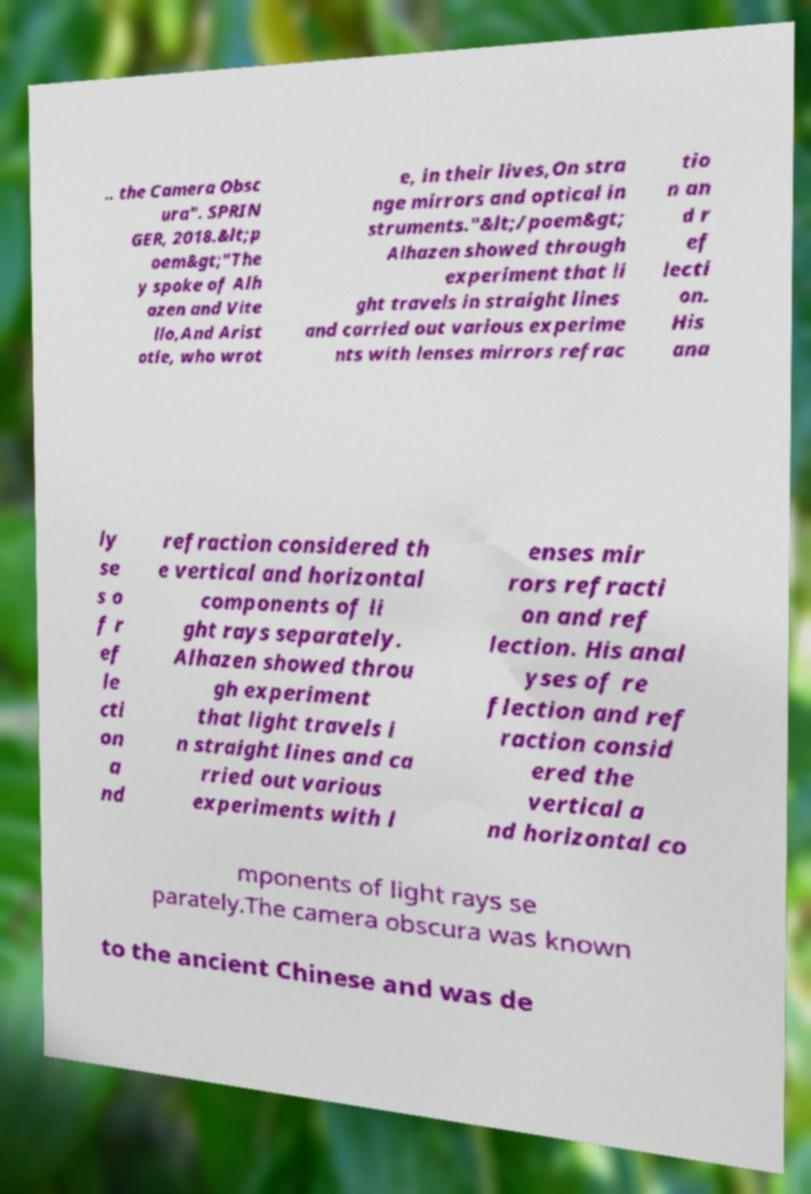Could you assist in decoding the text presented in this image and type it out clearly? .. the Camera Obsc ura". SPRIN GER, 2018.&lt;p oem&gt;"The y spoke of Alh azen and Vite llo,And Arist otle, who wrot e, in their lives,On stra nge mirrors and optical in struments."&lt;/poem&gt; Alhazen showed through experiment that li ght travels in straight lines and carried out various experime nts with lenses mirrors refrac tio n an d r ef lecti on. His ana ly se s o f r ef le cti on a nd refraction considered th e vertical and horizontal components of li ght rays separately. Alhazen showed throu gh experiment that light travels i n straight lines and ca rried out various experiments with l enses mir rors refracti on and ref lection. His anal yses of re flection and ref raction consid ered the vertical a nd horizontal co mponents of light rays se parately.The camera obscura was known to the ancient Chinese and was de 